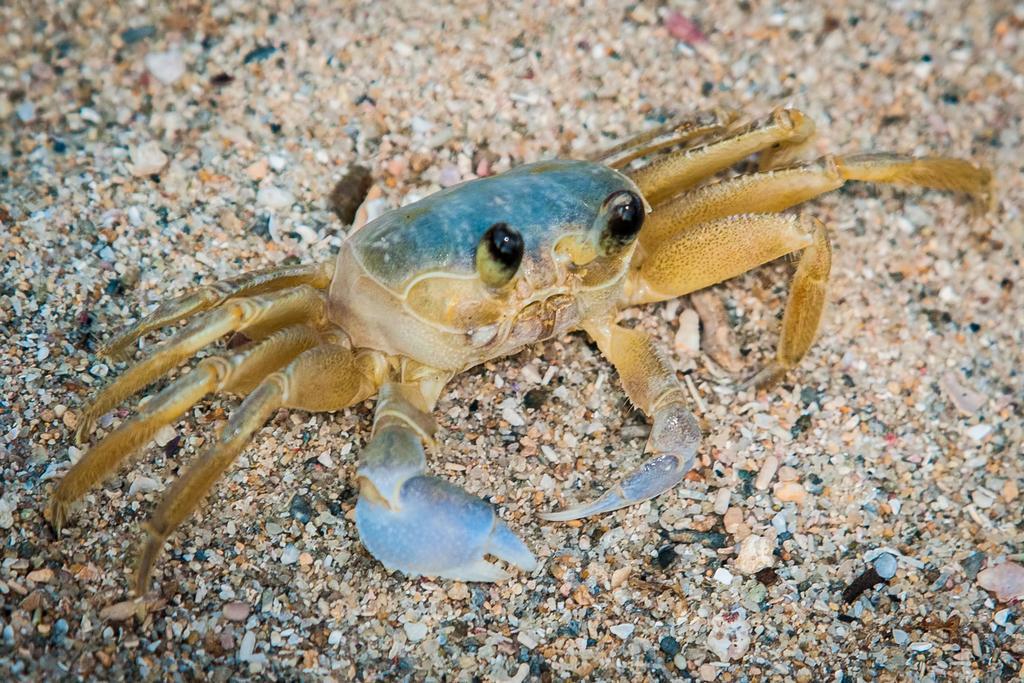Describe this image in one or two sentences. In this picture I can observe crab on the land in the middle of the picture. This crab is in blue and brown colors. 